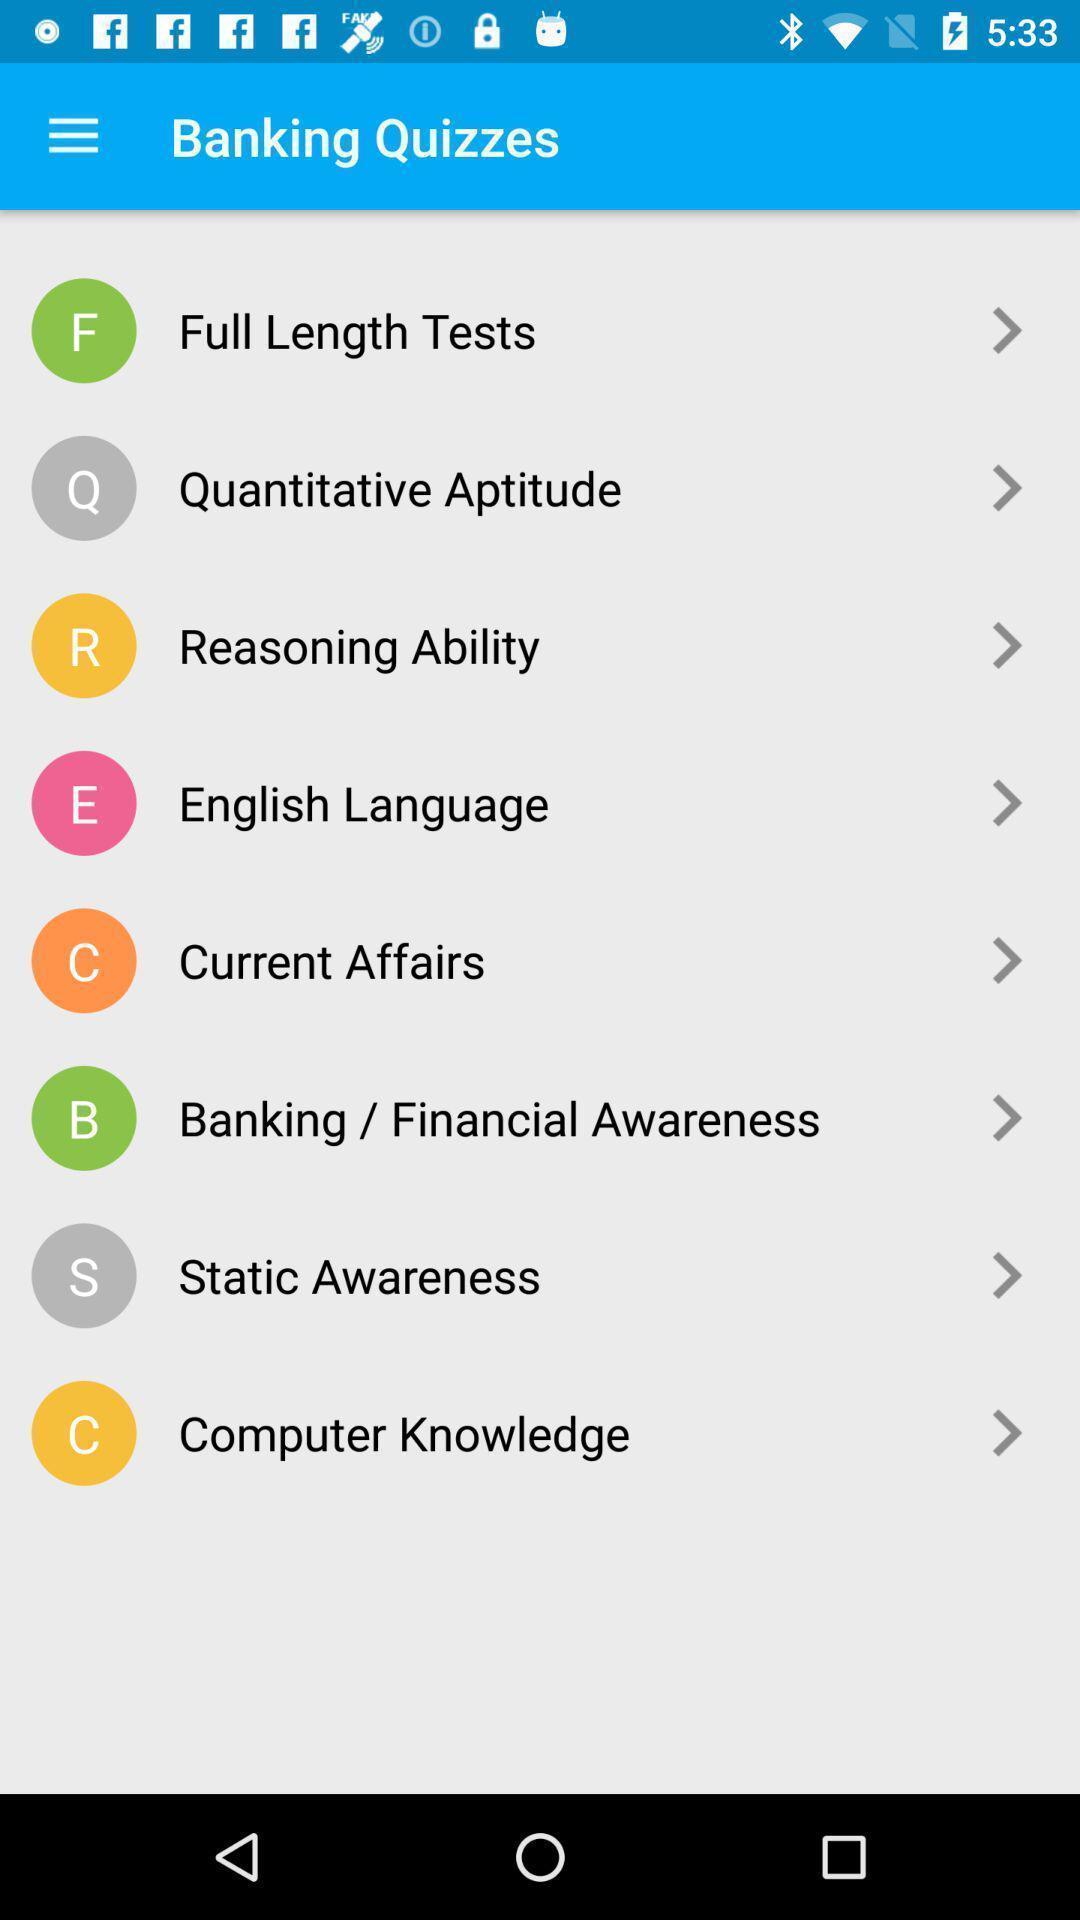Explain what's happening in this screen capture. Screen displaying the list of banking quizzes. 